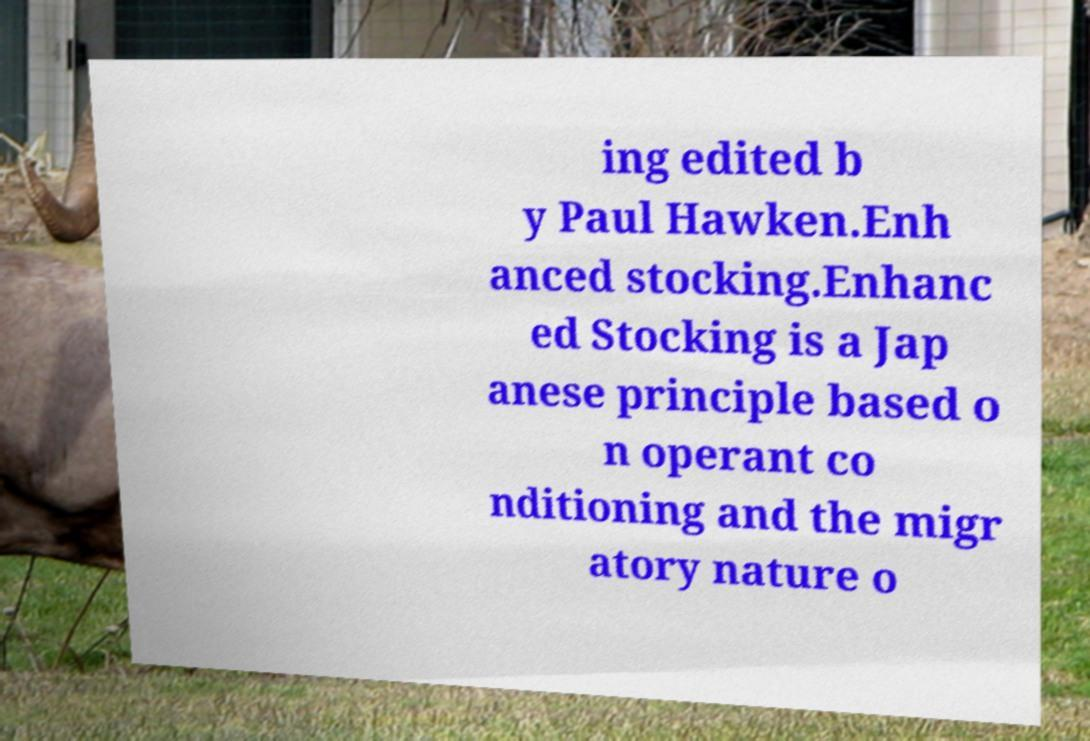Please read and relay the text visible in this image. What does it say? ing edited b y Paul Hawken.Enh anced stocking.Enhanc ed Stocking is a Jap anese principle based o n operant co nditioning and the migr atory nature o 